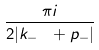Convert formula to latex. <formula><loc_0><loc_0><loc_500><loc_500>\frac { \pi i } { 2 | k _ { - } \ + p _ { - } | }</formula> 